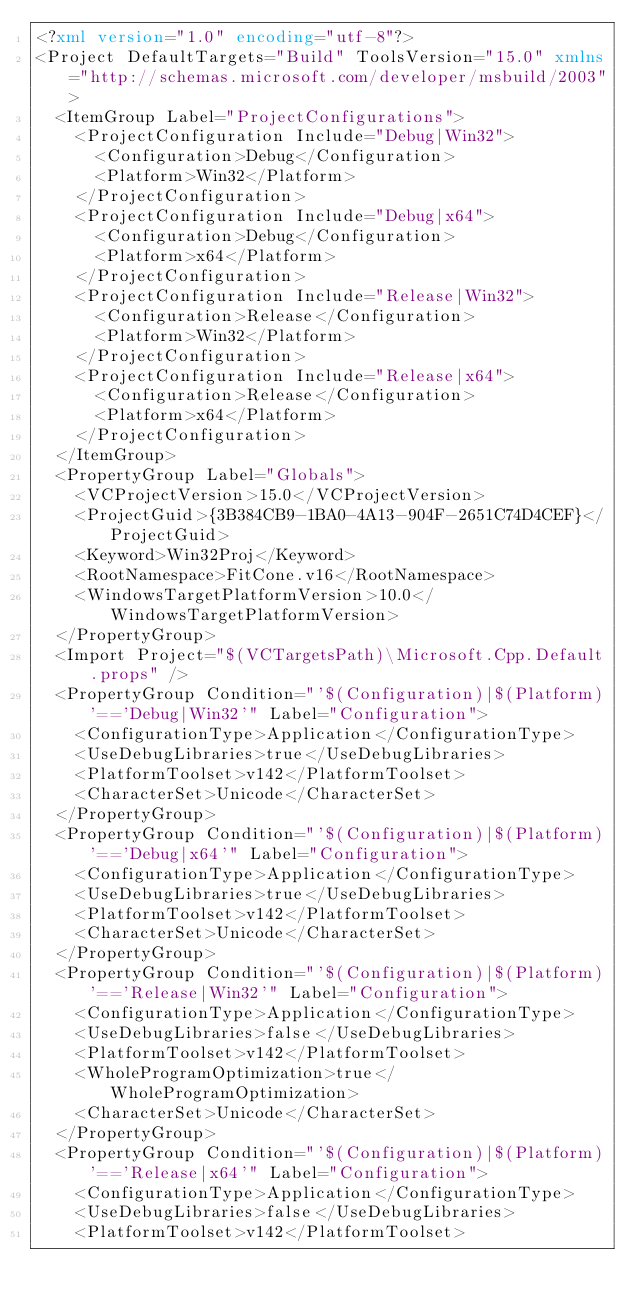Convert code to text. <code><loc_0><loc_0><loc_500><loc_500><_XML_><?xml version="1.0" encoding="utf-8"?>
<Project DefaultTargets="Build" ToolsVersion="15.0" xmlns="http://schemas.microsoft.com/developer/msbuild/2003">
  <ItemGroup Label="ProjectConfigurations">
    <ProjectConfiguration Include="Debug|Win32">
      <Configuration>Debug</Configuration>
      <Platform>Win32</Platform>
    </ProjectConfiguration>
    <ProjectConfiguration Include="Debug|x64">
      <Configuration>Debug</Configuration>
      <Platform>x64</Platform>
    </ProjectConfiguration>
    <ProjectConfiguration Include="Release|Win32">
      <Configuration>Release</Configuration>
      <Platform>Win32</Platform>
    </ProjectConfiguration>
    <ProjectConfiguration Include="Release|x64">
      <Configuration>Release</Configuration>
      <Platform>x64</Platform>
    </ProjectConfiguration>
  </ItemGroup>
  <PropertyGroup Label="Globals">
    <VCProjectVersion>15.0</VCProjectVersion>
    <ProjectGuid>{3B384CB9-1BA0-4A13-904F-2651C74D4CEF}</ProjectGuid>
    <Keyword>Win32Proj</Keyword>
    <RootNamespace>FitCone.v16</RootNamespace>
    <WindowsTargetPlatformVersion>10.0</WindowsTargetPlatformVersion>
  </PropertyGroup>
  <Import Project="$(VCTargetsPath)\Microsoft.Cpp.Default.props" />
  <PropertyGroup Condition="'$(Configuration)|$(Platform)'=='Debug|Win32'" Label="Configuration">
    <ConfigurationType>Application</ConfigurationType>
    <UseDebugLibraries>true</UseDebugLibraries>
    <PlatformToolset>v142</PlatformToolset>
    <CharacterSet>Unicode</CharacterSet>
  </PropertyGroup>
  <PropertyGroup Condition="'$(Configuration)|$(Platform)'=='Debug|x64'" Label="Configuration">
    <ConfigurationType>Application</ConfigurationType>
    <UseDebugLibraries>true</UseDebugLibraries>
    <PlatformToolset>v142</PlatformToolset>
    <CharacterSet>Unicode</CharacterSet>
  </PropertyGroup>
  <PropertyGroup Condition="'$(Configuration)|$(Platform)'=='Release|Win32'" Label="Configuration">
    <ConfigurationType>Application</ConfigurationType>
    <UseDebugLibraries>false</UseDebugLibraries>
    <PlatformToolset>v142</PlatformToolset>
    <WholeProgramOptimization>true</WholeProgramOptimization>
    <CharacterSet>Unicode</CharacterSet>
  </PropertyGroup>
  <PropertyGroup Condition="'$(Configuration)|$(Platform)'=='Release|x64'" Label="Configuration">
    <ConfigurationType>Application</ConfigurationType>
    <UseDebugLibraries>false</UseDebugLibraries>
    <PlatformToolset>v142</PlatformToolset></code> 